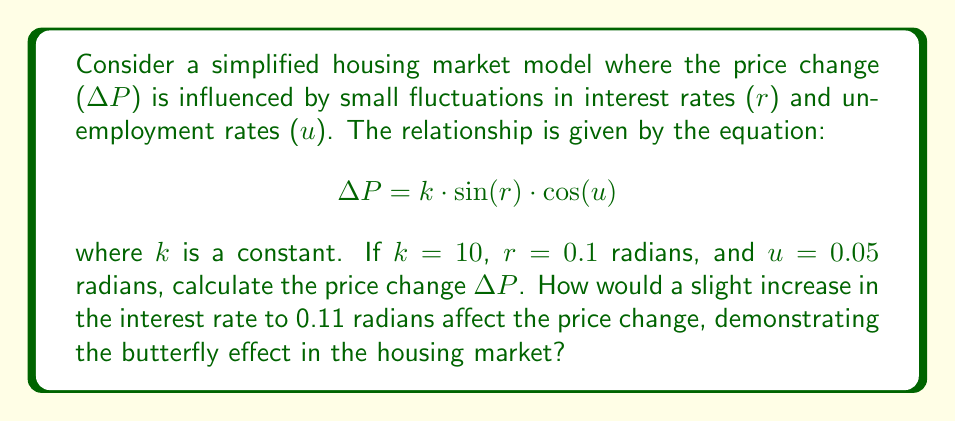Can you answer this question? 1. Let's first calculate $\Delta P$ with the initial values:
   $k = 10$, $r = 0.1$, $u = 0.05$

   $$\Delta P = 10 \cdot \sin(0.1) \cdot \cos(0.05)$$

2. Calculate $\sin(0.1)$:
   $\sin(0.1) \approx 0.0998$

3. Calculate $\cos(0.05)$:
   $\cos(0.05) \approx 0.9988$

4. Multiply the values:
   $$\Delta P = 10 \cdot 0.0998 \cdot 0.9988 \approx 0.9968$$

5. Now, let's calculate $\Delta P$ with the slightly increased interest rate:
   $r = 0.11$, keeping other values the same

   $$\Delta P_{new} = 10 \cdot \sin(0.11) \cdot \cos(0.05)$$

6. Calculate $\sin(0.11)$:
   $\sin(0.11) \approx 0.1097$

7. The new $\Delta P$ is:
   $$\Delta P_{new} = 10 \cdot 0.1097 \cdot 0.9988 \approx 1.0958$$

8. Calculate the difference:
   $$\Delta P_{new} - \Delta P = 1.0958 - 0.9968 = 0.0990$$

This small change in the interest rate (0.01 radians) resulted in a significant change in the price change (0.0990), demonstrating the butterfly effect in the housing market model.
Answer: $\Delta P \approx 0.9968$; $\Delta P_{new} \approx 1.0958$; Difference: 0.0990 